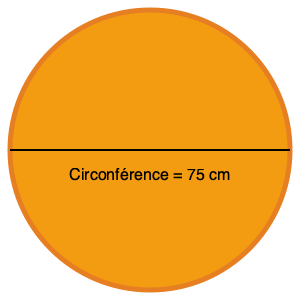Vous mesurez la circonférence d'un ballon de basket LNB Pro A et trouvez qu'elle est de 75 cm. En utilisant cette information, estimez le volume du ballon en centimètres cubes (cm³). Arrondissez votre réponse au centimètre cube le plus proche. Pour estimer le volume du ballon de basket, suivons ces étapes :

1) La formule du volume d'une sphère est $V = \frac{4}{3}\pi r^3$, où $r$ est le rayon.

2) Nous connaissons la circonférence ($C$), pas le rayon. La relation entre circonférence et rayon est $C = 2\pi r$.

3) Réarrangeons cette équation pour trouver $r$:
   $r = \frac{C}{2\pi}$

4) Substituons les valeurs connues :
   $r = \frac{75 \text{ cm}}{2\pi} \approx 11.94 \text{ cm}$

5) Maintenant, utilisons ce rayon dans la formule du volume :
   $V = \frac{4}{3}\pi (11.94 \text{ cm})^3$

6) Calculons :
   $V \approx 7156.52 \text{ cm}^3$

7) Arrondissons au centimètre cube le plus proche :
   $V \approx 7157 \text{ cm}^3$
Answer: 7157 cm³ 